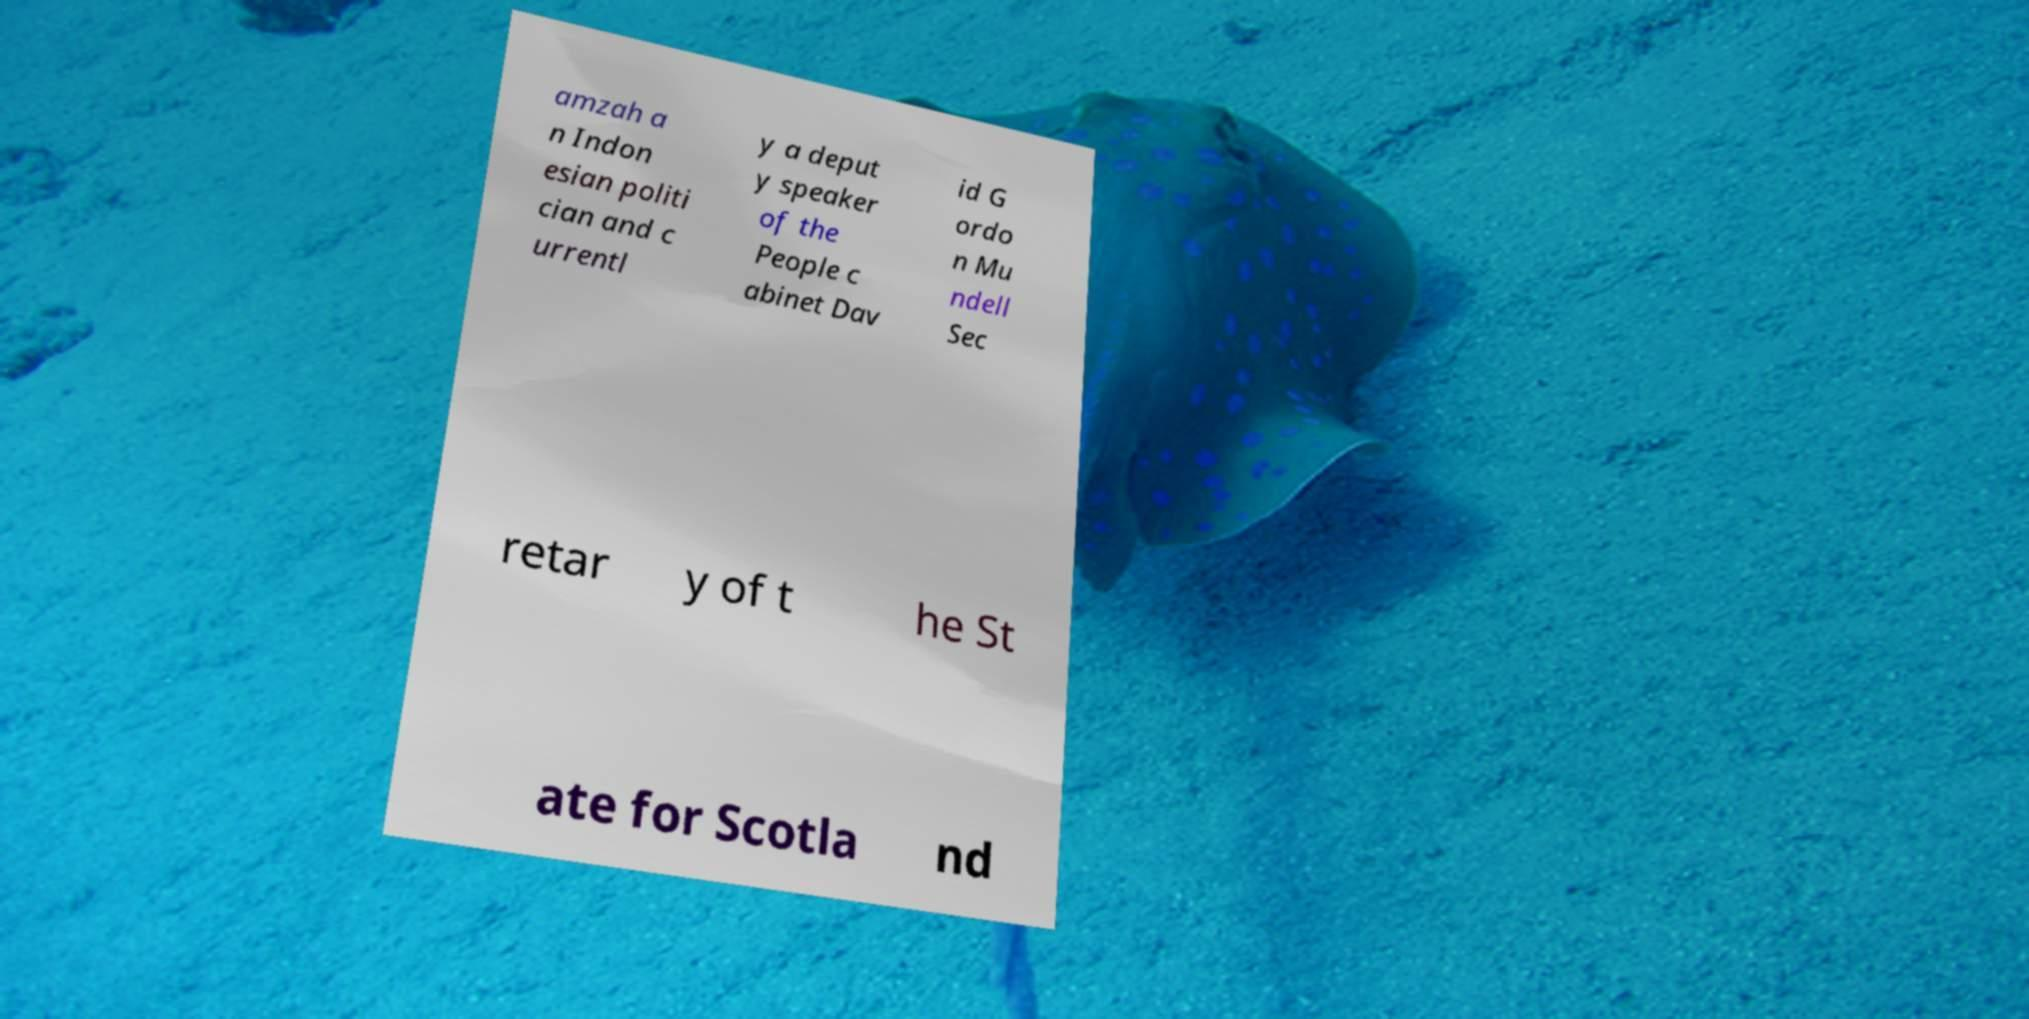For documentation purposes, I need the text within this image transcribed. Could you provide that? amzah a n Indon esian politi cian and c urrentl y a deput y speaker of the People c abinet Dav id G ordo n Mu ndell Sec retar y of t he St ate for Scotla nd 